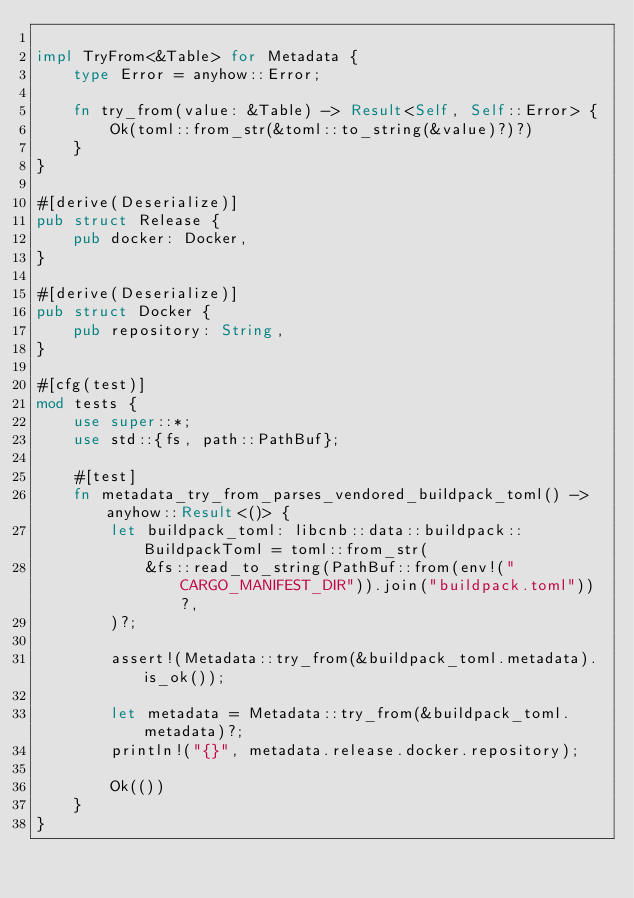<code> <loc_0><loc_0><loc_500><loc_500><_Rust_>
impl TryFrom<&Table> for Metadata {
    type Error = anyhow::Error;

    fn try_from(value: &Table) -> Result<Self, Self::Error> {
        Ok(toml::from_str(&toml::to_string(&value)?)?)
    }
}

#[derive(Deserialize)]
pub struct Release {
    pub docker: Docker,
}

#[derive(Deserialize)]
pub struct Docker {
    pub repository: String,
}

#[cfg(test)]
mod tests {
    use super::*;
    use std::{fs, path::PathBuf};

    #[test]
    fn metadata_try_from_parses_vendored_buildpack_toml() -> anyhow::Result<()> {
        let buildpack_toml: libcnb::data::buildpack::BuildpackToml = toml::from_str(
            &fs::read_to_string(PathBuf::from(env!("CARGO_MANIFEST_DIR")).join("buildpack.toml"))?,
        )?;

        assert!(Metadata::try_from(&buildpack_toml.metadata).is_ok());

        let metadata = Metadata::try_from(&buildpack_toml.metadata)?;
        println!("{}", metadata.release.docker.repository);

        Ok(())
    }
}
</code> 